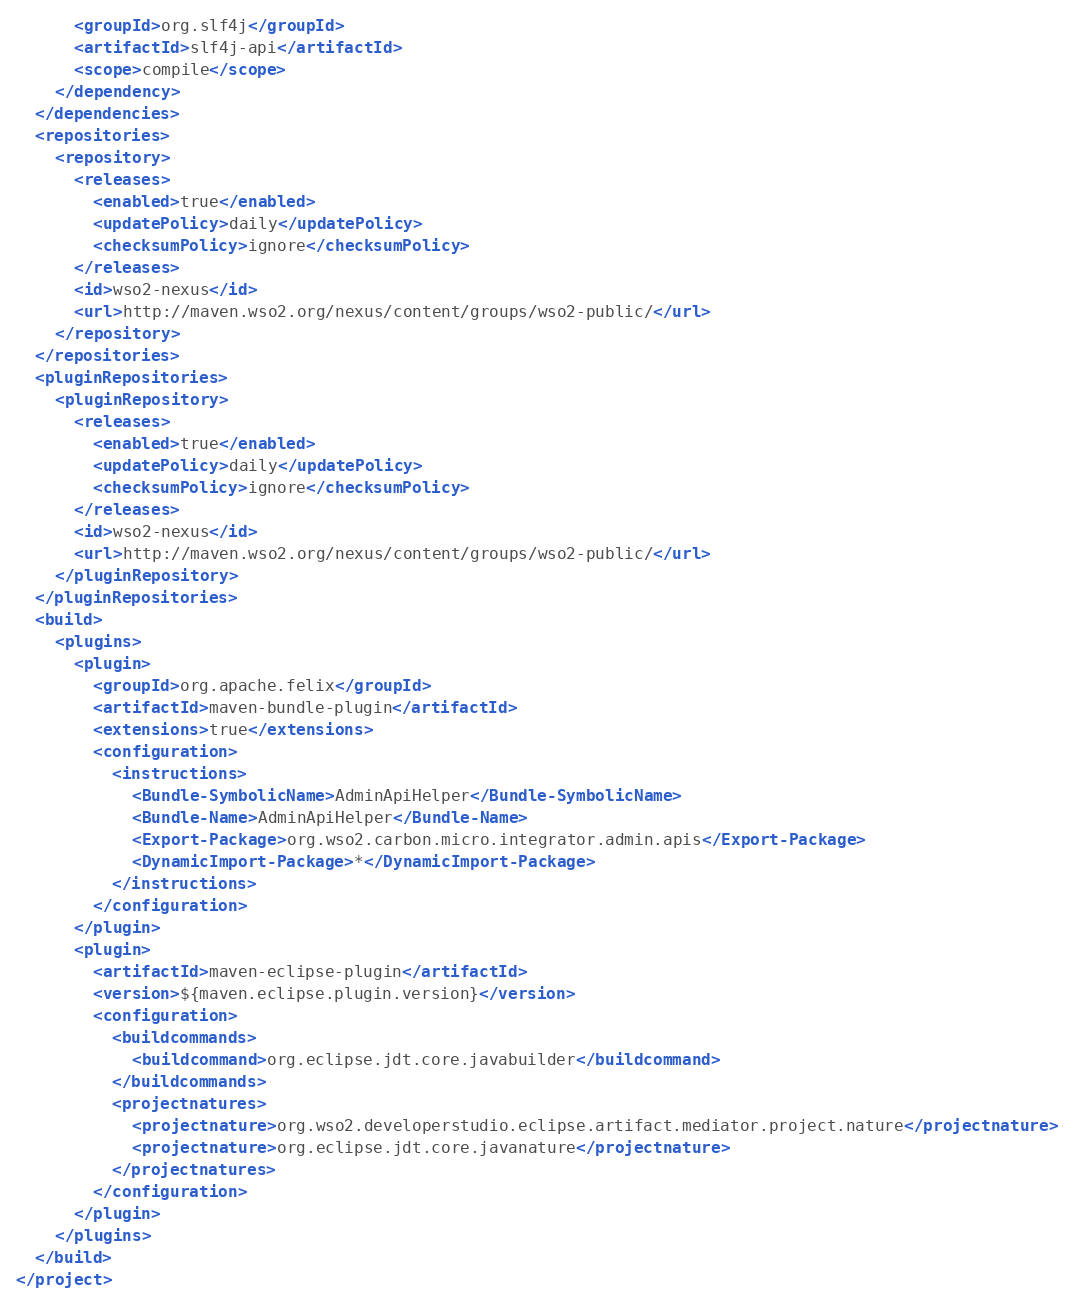<code> <loc_0><loc_0><loc_500><loc_500><_XML_>      <groupId>org.slf4j</groupId>
      <artifactId>slf4j-api</artifactId>
      <scope>compile</scope>
    </dependency>
  </dependencies>
  <repositories>
    <repository>
      <releases>
        <enabled>true</enabled>
        <updatePolicy>daily</updatePolicy>
        <checksumPolicy>ignore</checksumPolicy>
      </releases>
      <id>wso2-nexus</id>
      <url>http://maven.wso2.org/nexus/content/groups/wso2-public/</url>
    </repository>
  </repositories>
  <pluginRepositories>
    <pluginRepository>
      <releases>
        <enabled>true</enabled>
        <updatePolicy>daily</updatePolicy>
        <checksumPolicy>ignore</checksumPolicy>
      </releases>
      <id>wso2-nexus</id>
      <url>http://maven.wso2.org/nexus/content/groups/wso2-public/</url>
    </pluginRepository>
  </pluginRepositories>
  <build>
    <plugins>
      <plugin>
        <groupId>org.apache.felix</groupId>
        <artifactId>maven-bundle-plugin</artifactId>
        <extensions>true</extensions>
        <configuration>
          <instructions>
            <Bundle-SymbolicName>AdminApiHelper</Bundle-SymbolicName>
            <Bundle-Name>AdminApiHelper</Bundle-Name>
            <Export-Package>org.wso2.carbon.micro.integrator.admin.apis</Export-Package>
            <DynamicImport-Package>*</DynamicImport-Package>
          </instructions>
        </configuration>
      </plugin>
      <plugin>
        <artifactId>maven-eclipse-plugin</artifactId>
        <version>${maven.eclipse.plugin.version}</version>
        <configuration>
          <buildcommands>
            <buildcommand>org.eclipse.jdt.core.javabuilder</buildcommand>
          </buildcommands>
          <projectnatures>
            <projectnature>org.wso2.developerstudio.eclipse.artifact.mediator.project.nature</projectnature>
            <projectnature>org.eclipse.jdt.core.javanature</projectnature>
          </projectnatures>
        </configuration>
      </plugin>
    </plugins>
  </build>
</project>
</code> 